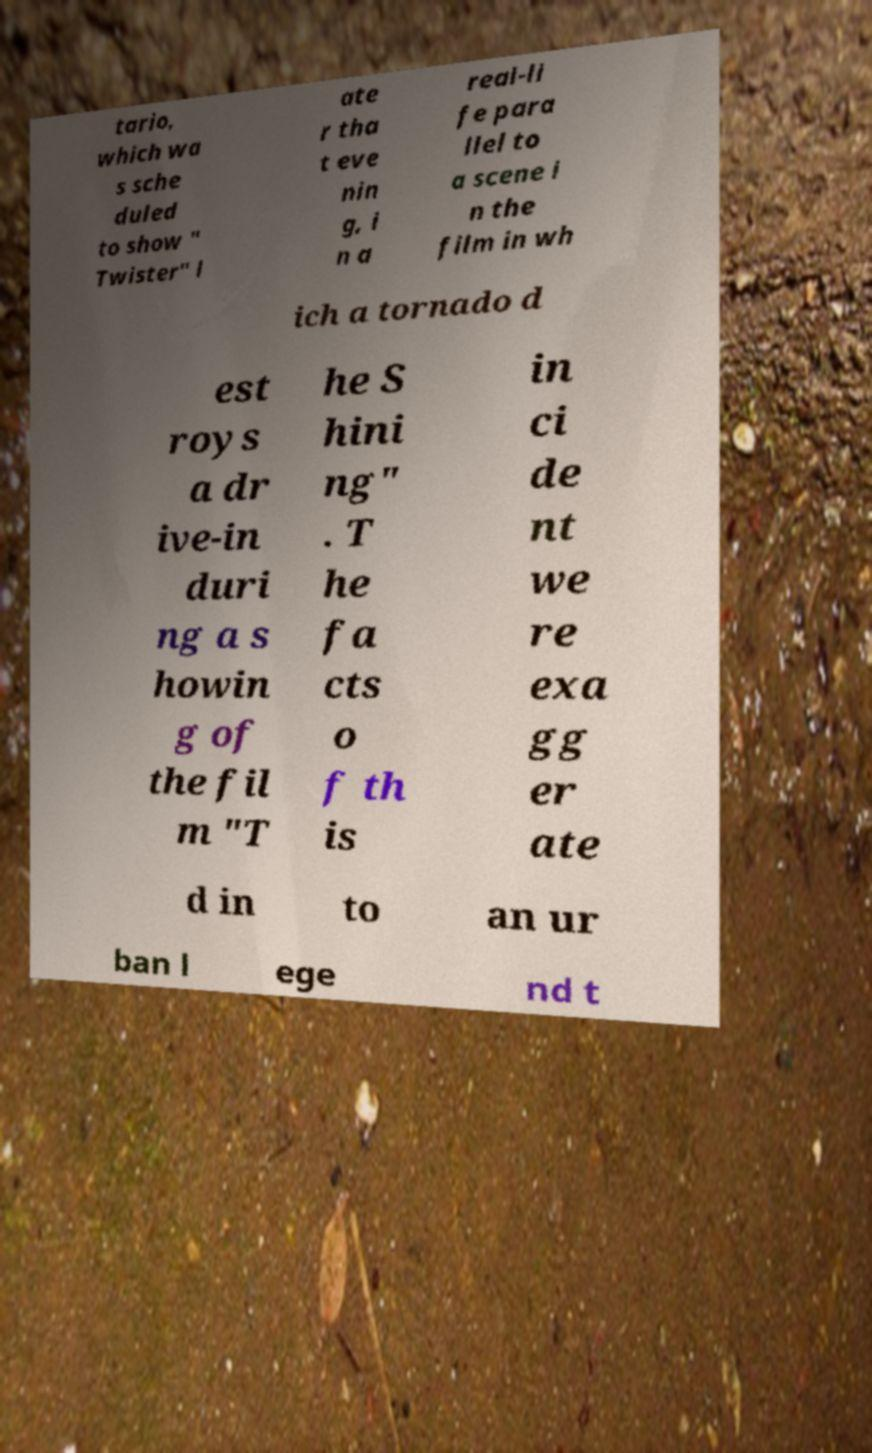Can you accurately transcribe the text from the provided image for me? tario, which wa s sche duled to show " Twister" l ate r tha t eve nin g, i n a real-li fe para llel to a scene i n the film in wh ich a tornado d est roys a dr ive-in duri ng a s howin g of the fil m "T he S hini ng" . T he fa cts o f th is in ci de nt we re exa gg er ate d in to an ur ban l ege nd t 